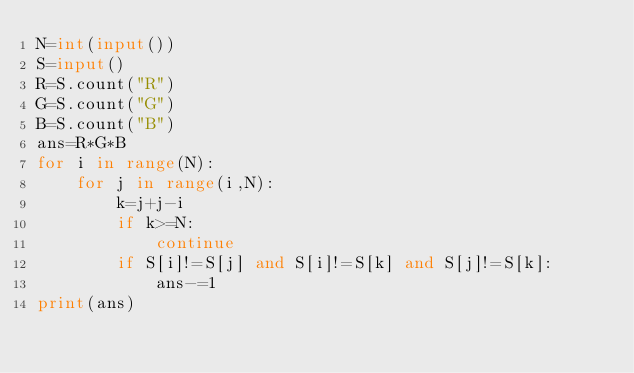Convert code to text. <code><loc_0><loc_0><loc_500><loc_500><_Python_>N=int(input())
S=input()
R=S.count("R")
G=S.count("G")
B=S.count("B")
ans=R*G*B
for i in range(N):
    for j in range(i,N):
        k=j+j-i
        if k>=N:
            continue
        if S[i]!=S[j] and S[i]!=S[k] and S[j]!=S[k]:
            ans-=1
print(ans)
</code> 